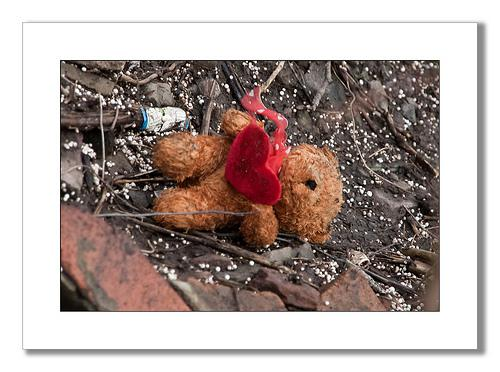Question: why is the main focus of the picture?
Choices:
A. A stuffed animal.
B. Pooh bear.
C. A stuffed pig.
D. A teddy bear.
Answer with the letter. Answer: D Question: how is the bear positioned?
Choices:
A. Laying down.
B. Standing up.
C. Sitting down.
D. Climbing the tree.
Answer with the letter. Answer: A Question: when was the picture taken?
Choices:
A. During the night.
B. During the day.
C. During the morning.
D. During the evening.
Answer with the letter. Answer: B Question: what is the bear on?
Choices:
A. The tree.
B. The rock.
C. The ground.
D. The hill.
Answer with the letter. Answer: C 